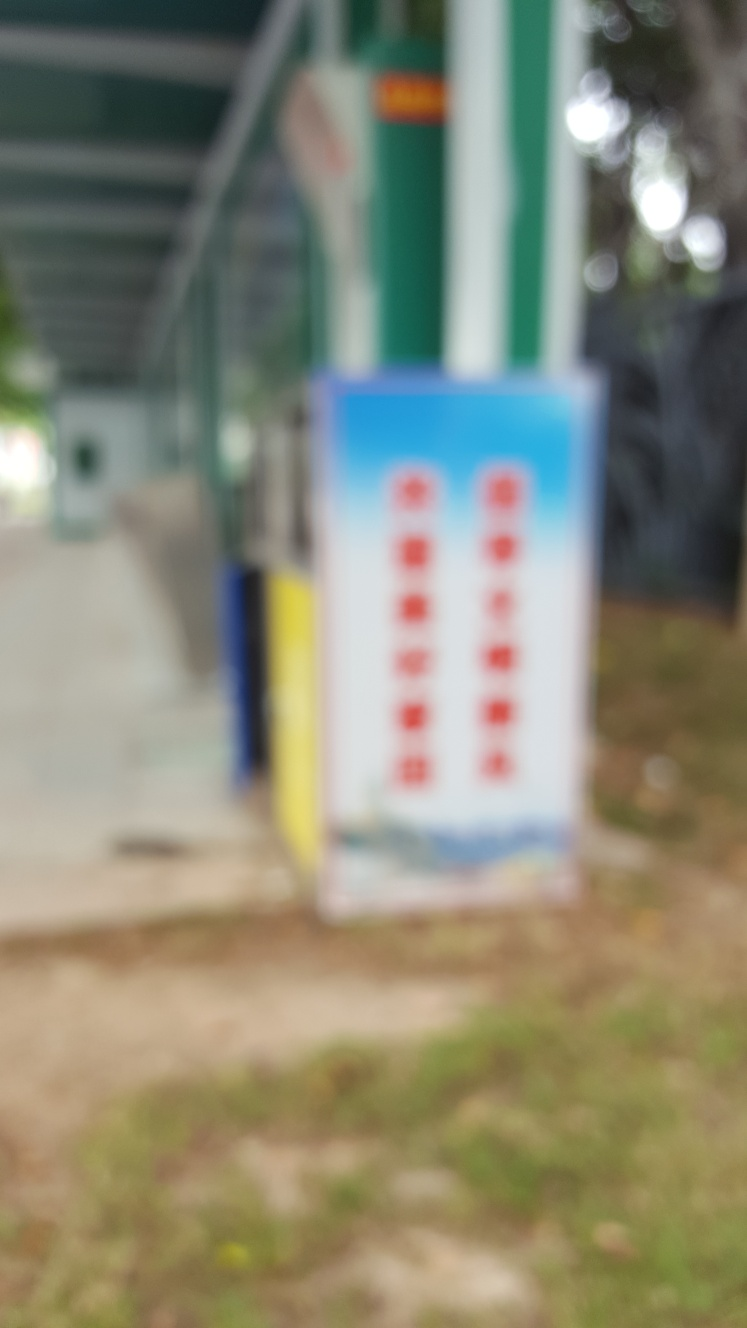How is the subject of the photograph? The photograph's subject is blurred, making it difficult to discern specific details. This could be due to motion, a camera focus issue, or an artistic choice to emphasize other aspects of the scene. 